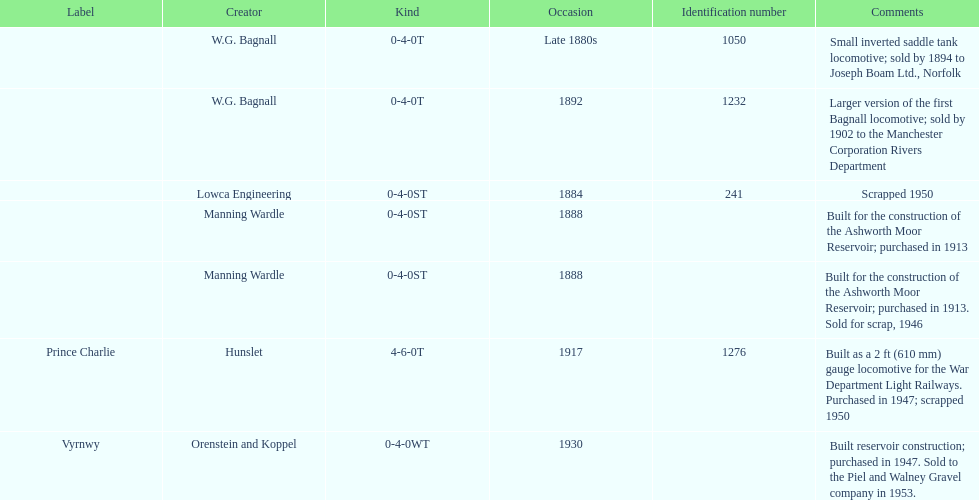How many locomotives were built before the 1900s? 5. Can you parse all the data within this table? {'header': ['Label', 'Creator', 'Kind', 'Occasion', 'Identification number', 'Comments'], 'rows': [['', 'W.G. Bagnall', '0-4-0T', 'Late 1880s', '1050', 'Small inverted saddle tank locomotive; sold by 1894 to Joseph Boam Ltd., Norfolk'], ['', 'W.G. Bagnall', '0-4-0T', '1892', '1232', 'Larger version of the first Bagnall locomotive; sold by 1902 to the Manchester Corporation Rivers Department'], ['', 'Lowca Engineering', '0-4-0ST', '1884', '241', 'Scrapped 1950'], ['', 'Manning Wardle', '0-4-0ST', '1888', '', 'Built for the construction of the Ashworth Moor Reservoir; purchased in 1913'], ['', 'Manning Wardle', '0-4-0ST', '1888', '', 'Built for the construction of the Ashworth Moor Reservoir; purchased in 1913. Sold for scrap, 1946'], ['Prince Charlie', 'Hunslet', '4-6-0T', '1917', '1276', 'Built as a 2\xa0ft (610\xa0mm) gauge locomotive for the War Department Light Railways. Purchased in 1947; scrapped 1950'], ['Vyrnwy', 'Orenstein and Koppel', '0-4-0WT', '1930', '', 'Built reservoir construction; purchased in 1947. Sold to the Piel and Walney Gravel company in 1953.']]} 